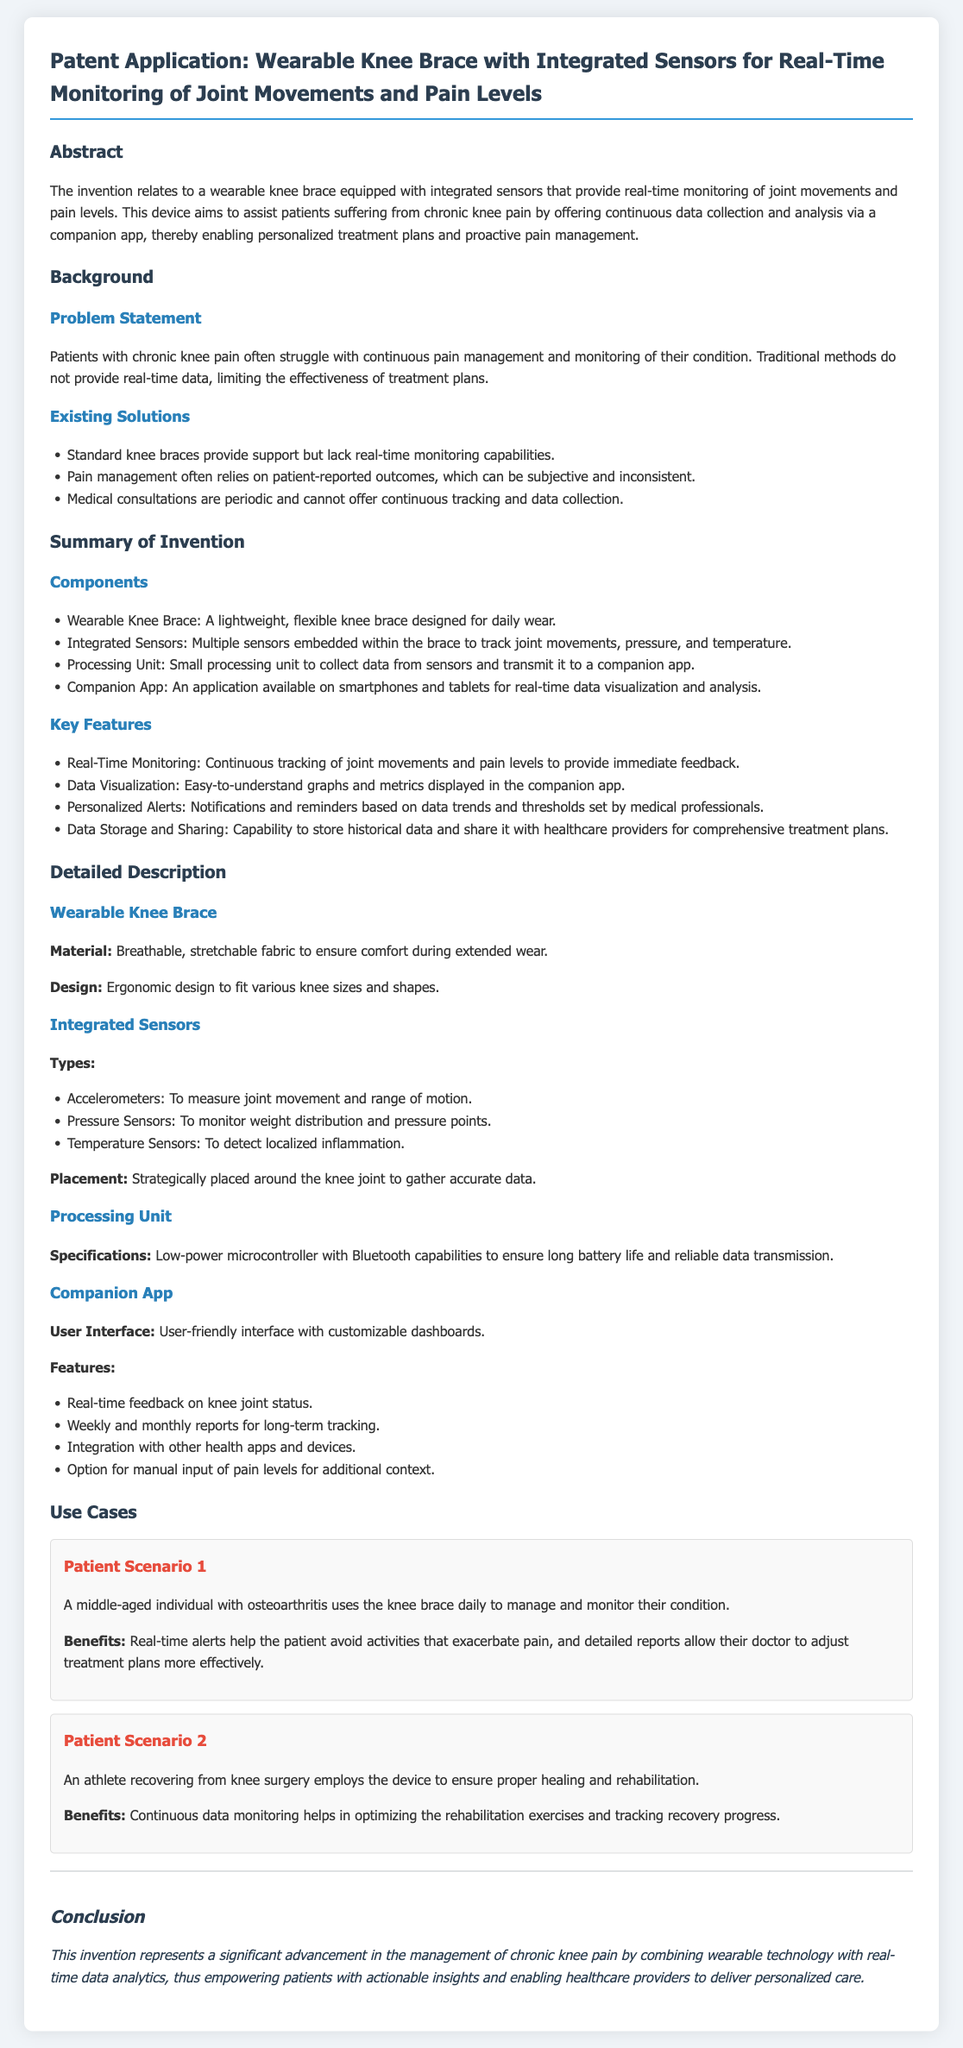What is the primary purpose of the wearable knee brace? The primary purpose is to assist patients suffering from chronic knee pain by offering continuous data collection and analysis.
Answer: assist patients suffering from chronic knee pain What types of sensors are embedded in the knee brace? The types of sensors include accelerometers, pressure sensors, and temperature sensors.
Answer: accelerometers, pressure sensors, temperature sensors What feature allows for immediate feedback on joint movements? The feature that allows for immediate feedback is real-time monitoring.
Answer: real-time monitoring How does the companion app help patients? The app helps patients by providing data visualization and analysis for their knee health.
Answer: data visualization and analysis What is the material of the wearable knee brace? The material of the knee brace is breathable, stretchable fabric.
Answer: breathable, stretchable fabric How does the design of the knee brace accommodate different users? The design is ergonomic to fit various knee sizes and shapes.
Answer: ergonomic design What is the benefit for the middle-aged individual with osteoarthritis? The benefit is that real-time alerts help the patient avoid activities that exacerbate pain.
Answer: real-time alerts What capability does the processing unit have? The processing unit has Bluetooth capabilities.
Answer: Bluetooth capabilities What conclusion is drawn about the invention's impact? The conclusion is that it empowers patients with actionable insights and enables personalized care.
Answer: empowers patients with actionable insights and enables personalized care 